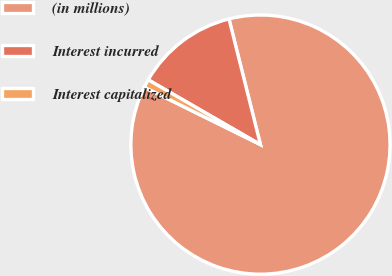Convert chart. <chart><loc_0><loc_0><loc_500><loc_500><pie_chart><fcel>(in millions)<fcel>Interest incurred<fcel>Interest capitalized<nl><fcel>86.21%<fcel>12.76%<fcel>1.03%<nl></chart> 